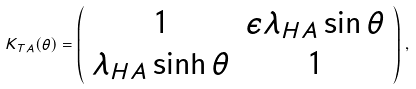Convert formula to latex. <formula><loc_0><loc_0><loc_500><loc_500>K _ { T A } ( \theta ) = \left ( \begin{array} { c c } 1 & \epsilon \lambda _ { H A } \sin \theta \\ \lambda _ { H A } \sinh \theta & 1 \end{array} \right ) \, ,</formula> 